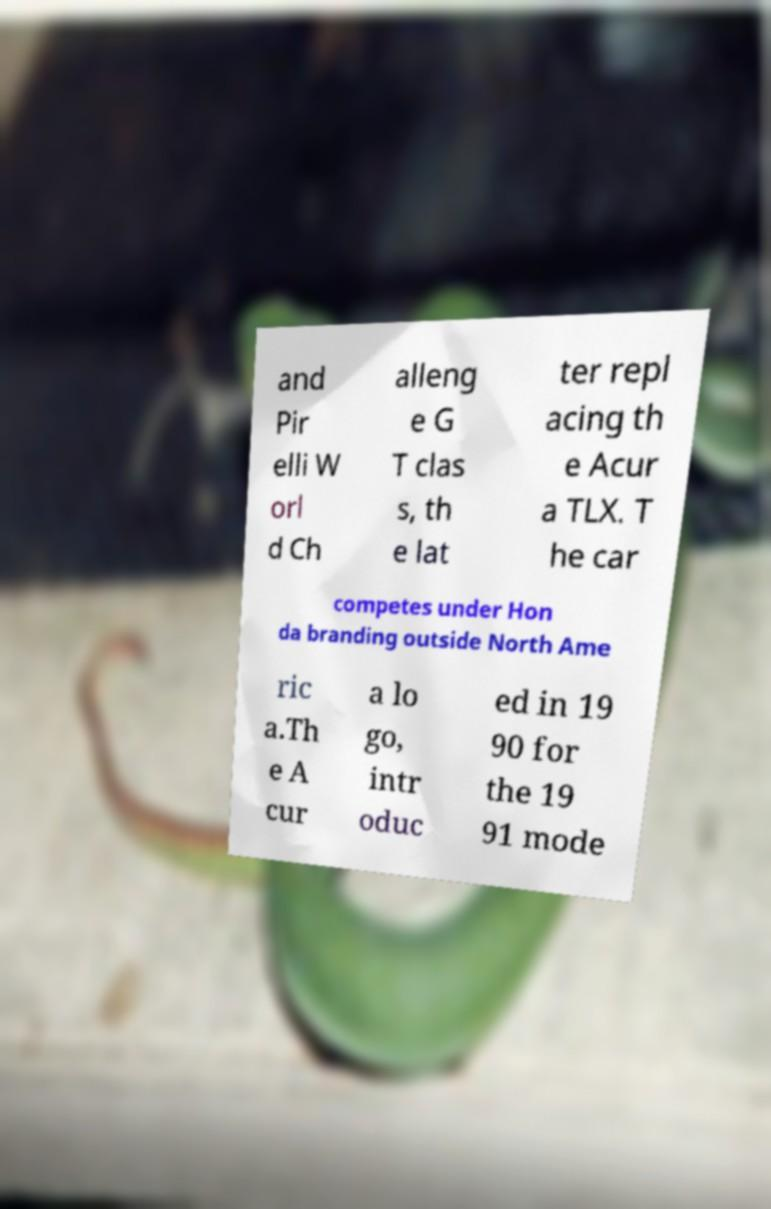For documentation purposes, I need the text within this image transcribed. Could you provide that? and Pir elli W orl d Ch alleng e G T clas s, th e lat ter repl acing th e Acur a TLX. T he car competes under Hon da branding outside North Ame ric a.Th e A cur a lo go, intr oduc ed in 19 90 for the 19 91 mode 